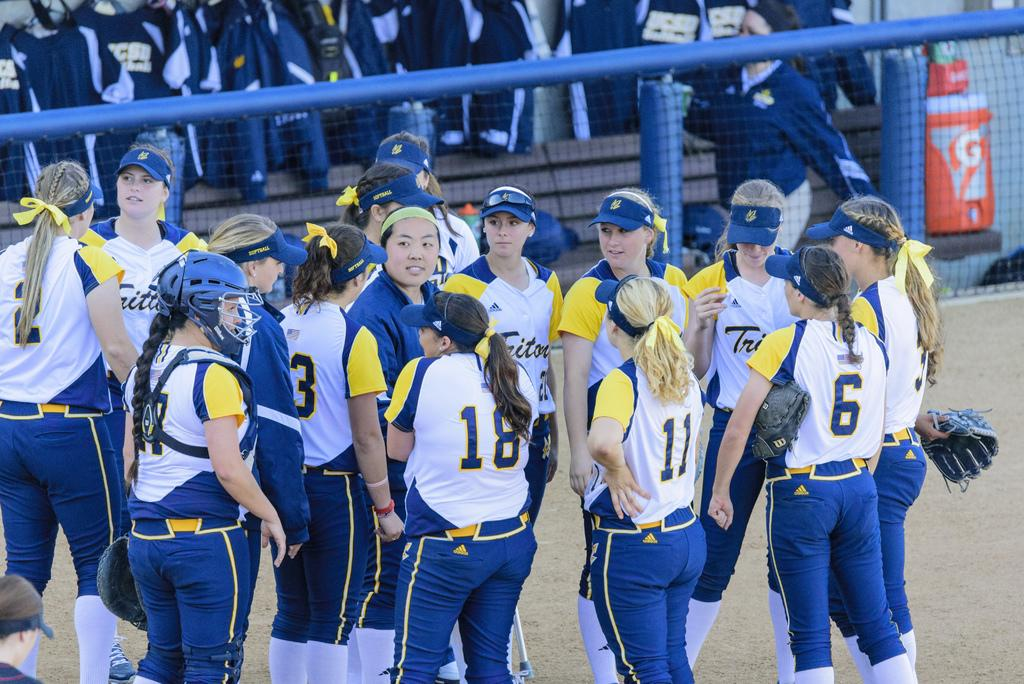<image>
Present a compact description of the photo's key features. A group of female athletes, 18 11 and 6 are in the center 